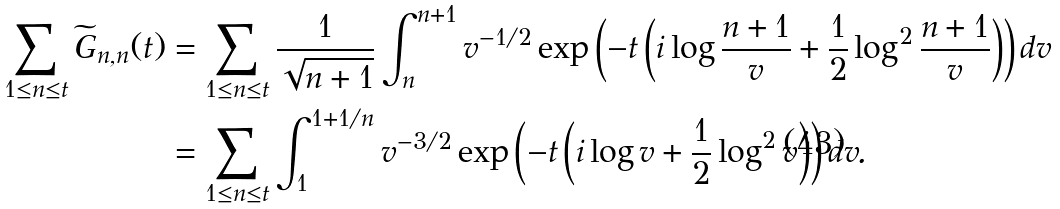<formula> <loc_0><loc_0><loc_500><loc_500>\sum _ { 1 \leq n \leq t } \widetilde { G } _ { n , n } ( t ) & = \sum _ { 1 \leq n \leq t } \frac { 1 } { \sqrt { n + 1 } } \int _ { n } ^ { n + 1 } v ^ { - 1 / 2 } \exp \left ( - t \left ( i \log { \frac { n + 1 } { v } } + \frac { 1 } { 2 } \log ^ { 2 } { \frac { n + 1 } { v } } \right ) \right ) d v \\ & = \sum _ { 1 \leq n \leq t } \int _ { 1 } ^ { 1 + 1 / n } v ^ { - 3 / 2 } \exp \left ( - t \left ( i \log v + \frac { 1 } { 2 } \log ^ { 2 } v \right ) \right ) d v .</formula> 